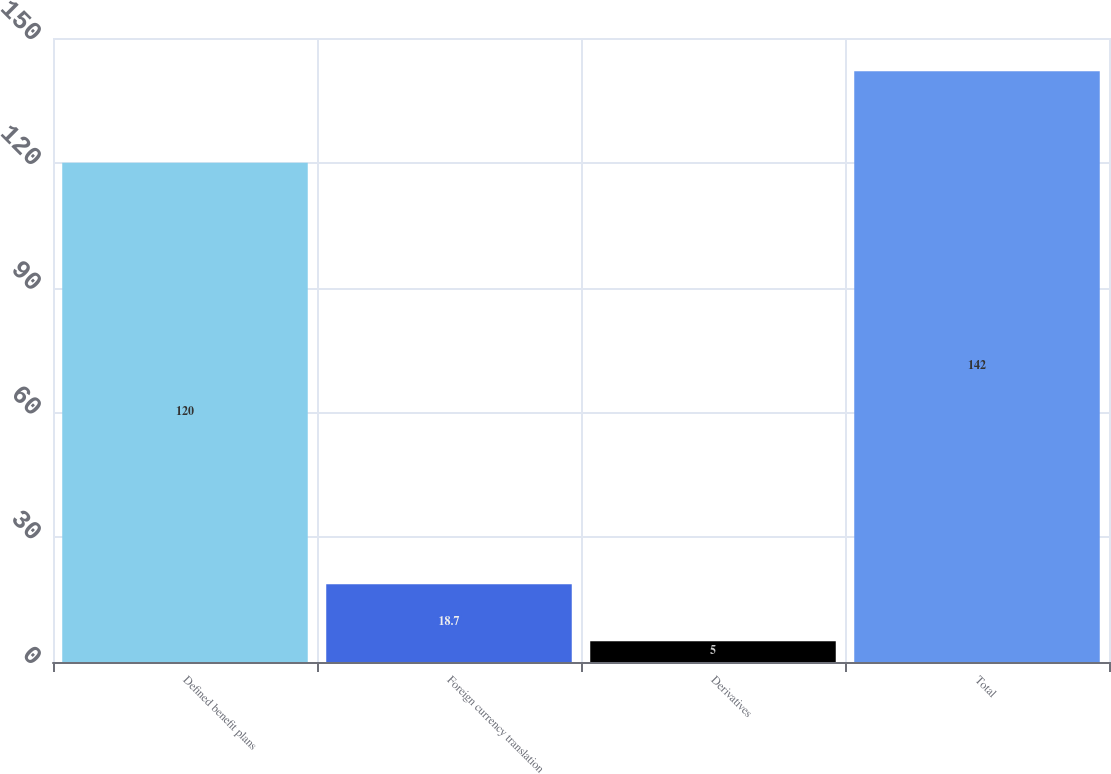Convert chart. <chart><loc_0><loc_0><loc_500><loc_500><bar_chart><fcel>Defined benefit plans<fcel>Foreign currency translation<fcel>Derivatives<fcel>Total<nl><fcel>120<fcel>18.7<fcel>5<fcel>142<nl></chart> 